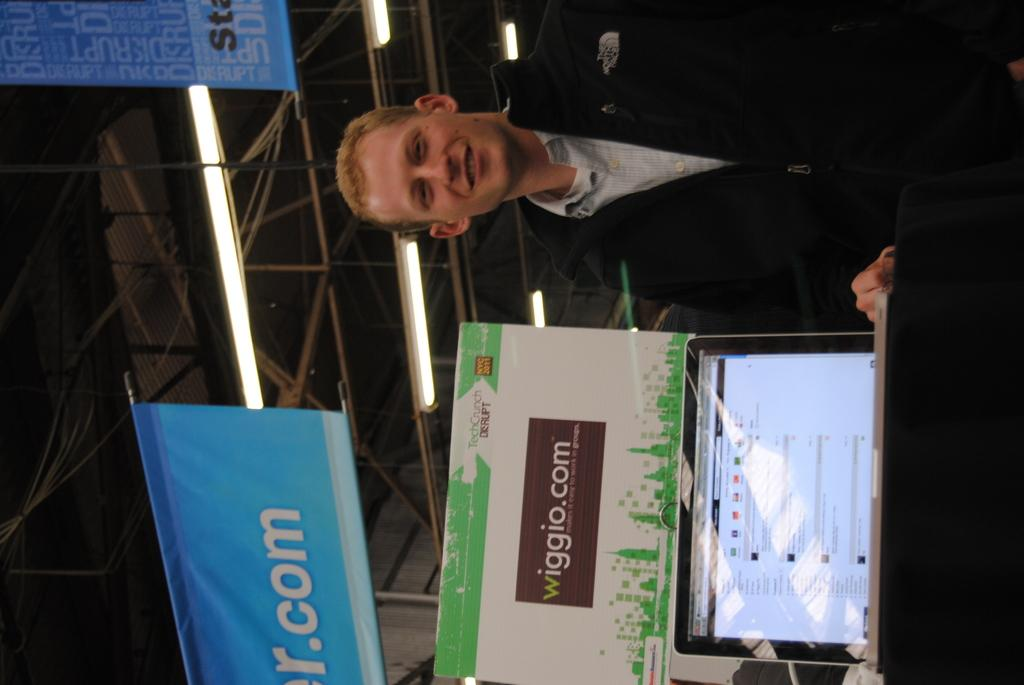What is the person in the image wearing? The person is wearing a black coat. What electronic device is present in the image? There is a laptop in the image. What type of object can be seen in the image that might be used for writing or displaying information? There is a board in the image. What color are the banners in the image? The banners in the image are blue. What can be seen at the top of the image? There are lights and poles visible at the top of the image. How many mice are running on the laptop in the image? There are no mice visible on the laptop in the image. 